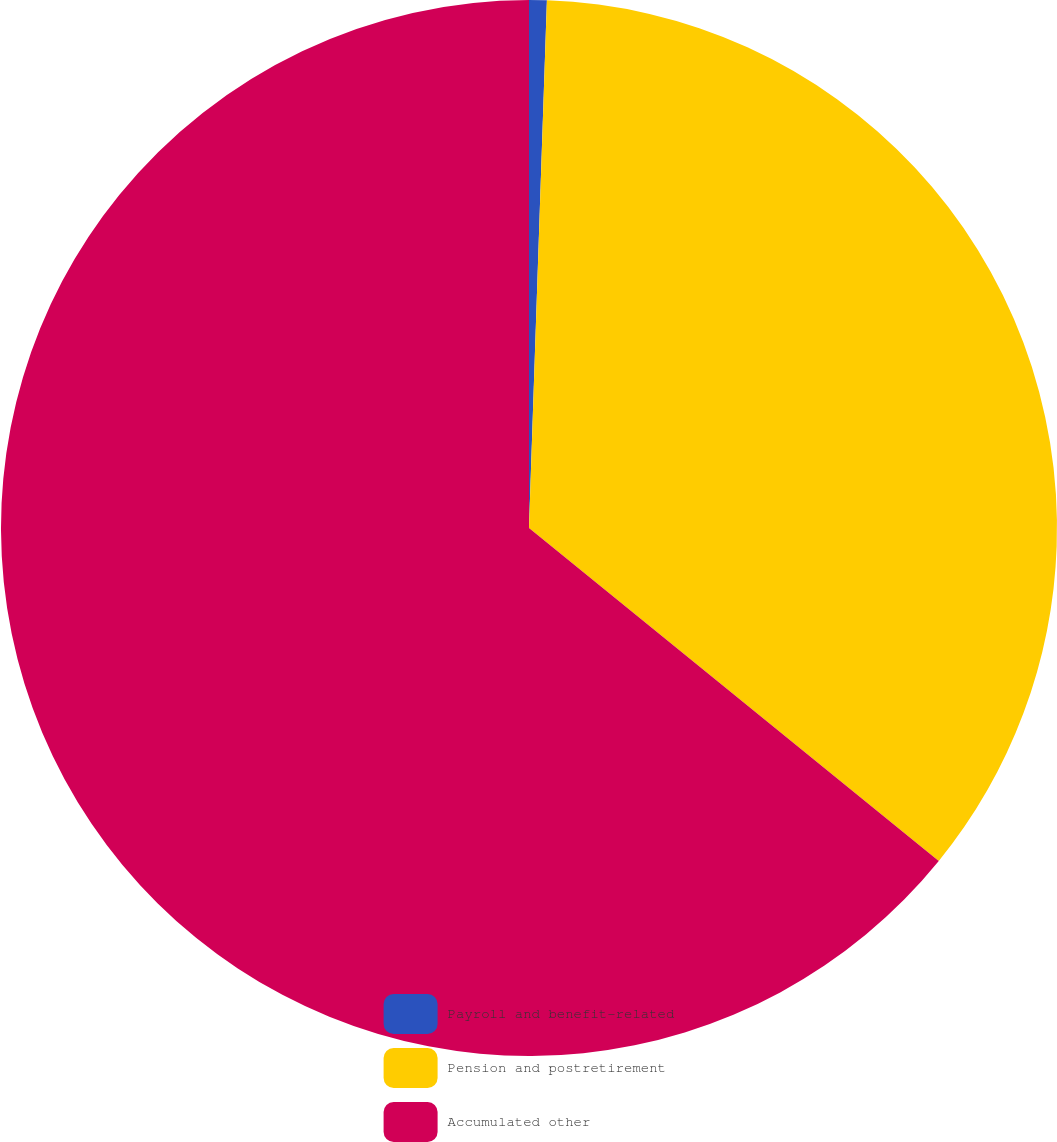<chart> <loc_0><loc_0><loc_500><loc_500><pie_chart><fcel>Payroll and benefit-related<fcel>Pension and postretirement<fcel>Accumulated other<nl><fcel>0.54%<fcel>35.32%<fcel>64.14%<nl></chart> 